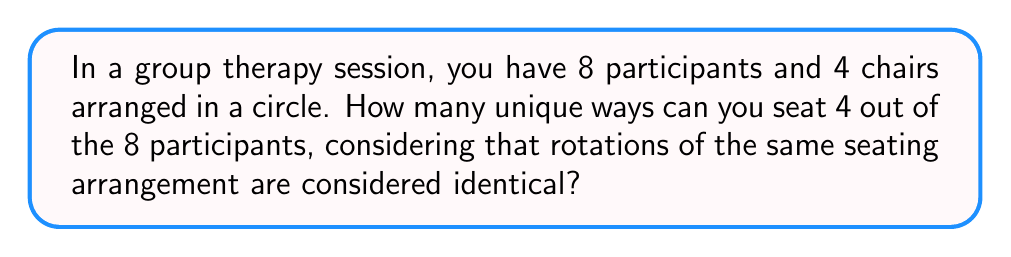Solve this math problem. Let's approach this step-by-step:

1) First, we need to choose 4 participants out of 8. This can be done in $\binom{8}{4}$ ways.

   $\binom{8}{4} = \frac{8!}{4!(8-4)!} = \frac{8!}{4!4!} = 70$

2) Now, for each selection of 4 participants, we need to arrange them in the 4 chairs. Normally, this would be 4! = 24 ways.

3) However, the question states that rotations of the same seating arrangement are considered identical. This means that for each unique arrangement, there are 4 rotations that are considered the same.

4) To account for this, we need to divide our total arrangements by 4.

5) Therefore, the total number of unique seating arrangements is:

   $$\frac{\binom{8}{4} \times 4!}{4} = \frac{70 \times 24}{4} = 420$$

This calculation combines the number of ways to choose 4 out of 8 participants, the number of ways to arrange 4 people, and then adjusts for the rotational symmetry of the circle.
Answer: 420 